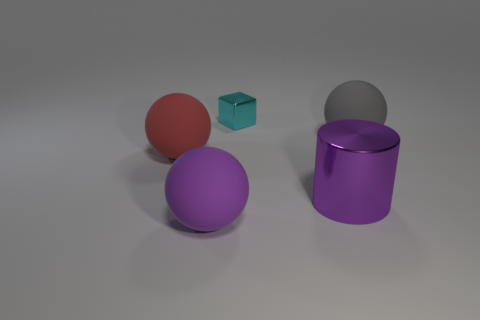Are there more large shiny cylinders in front of the tiny metallic object than gray matte things that are to the left of the red thing?
Your response must be concise. Yes. There is a large purple thing that is made of the same material as the cyan cube; what shape is it?
Provide a short and direct response. Cylinder. How many other objects are there of the same shape as the large purple matte object?
Ensure brevity in your answer.  2. There is a matte object that is right of the big purple sphere; what is its shape?
Provide a short and direct response. Sphere. The small cube has what color?
Your response must be concise. Cyan. How many other objects are the same size as the cube?
Keep it short and to the point. 0. There is a purple thing to the left of the object behind the gray rubber sphere; what is it made of?
Provide a succinct answer. Rubber. There is a red thing; is it the same size as the matte ball on the right side of the cyan metal block?
Provide a succinct answer. Yes. Is there a large rubber thing of the same color as the cylinder?
Your answer should be compact. Yes. How many tiny objects are either cyan blocks or red rubber objects?
Give a very brief answer. 1. 